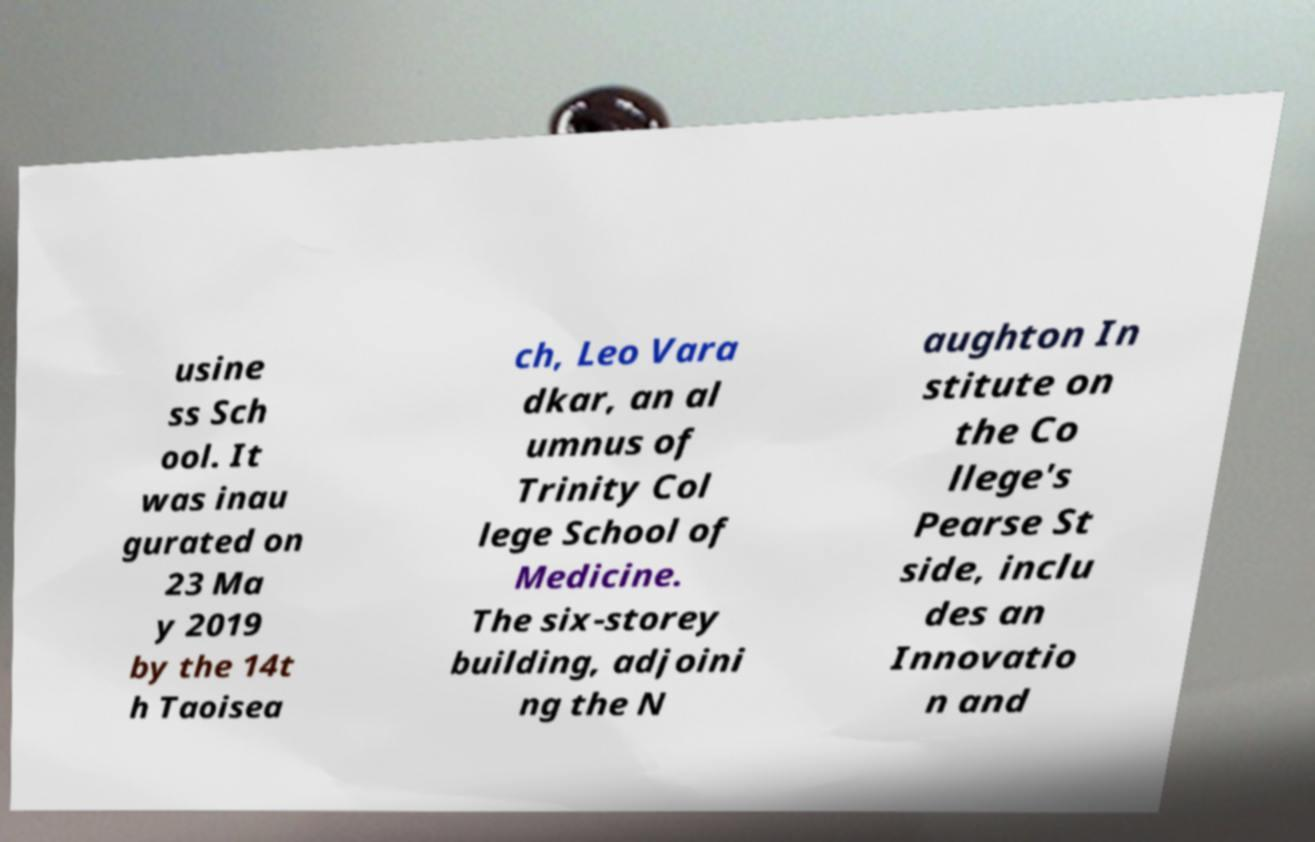Please read and relay the text visible in this image. What does it say? usine ss Sch ool. It was inau gurated on 23 Ma y 2019 by the 14t h Taoisea ch, Leo Vara dkar, an al umnus of Trinity Col lege School of Medicine. The six-storey building, adjoini ng the N aughton In stitute on the Co llege's Pearse St side, inclu des an Innovatio n and 